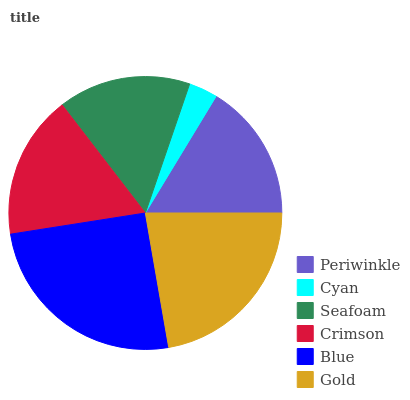Is Cyan the minimum?
Answer yes or no. Yes. Is Blue the maximum?
Answer yes or no. Yes. Is Seafoam the minimum?
Answer yes or no. No. Is Seafoam the maximum?
Answer yes or no. No. Is Seafoam greater than Cyan?
Answer yes or no. Yes. Is Cyan less than Seafoam?
Answer yes or no. Yes. Is Cyan greater than Seafoam?
Answer yes or no. No. Is Seafoam less than Cyan?
Answer yes or no. No. Is Crimson the high median?
Answer yes or no. Yes. Is Periwinkle the low median?
Answer yes or no. Yes. Is Periwinkle the high median?
Answer yes or no. No. Is Cyan the low median?
Answer yes or no. No. 